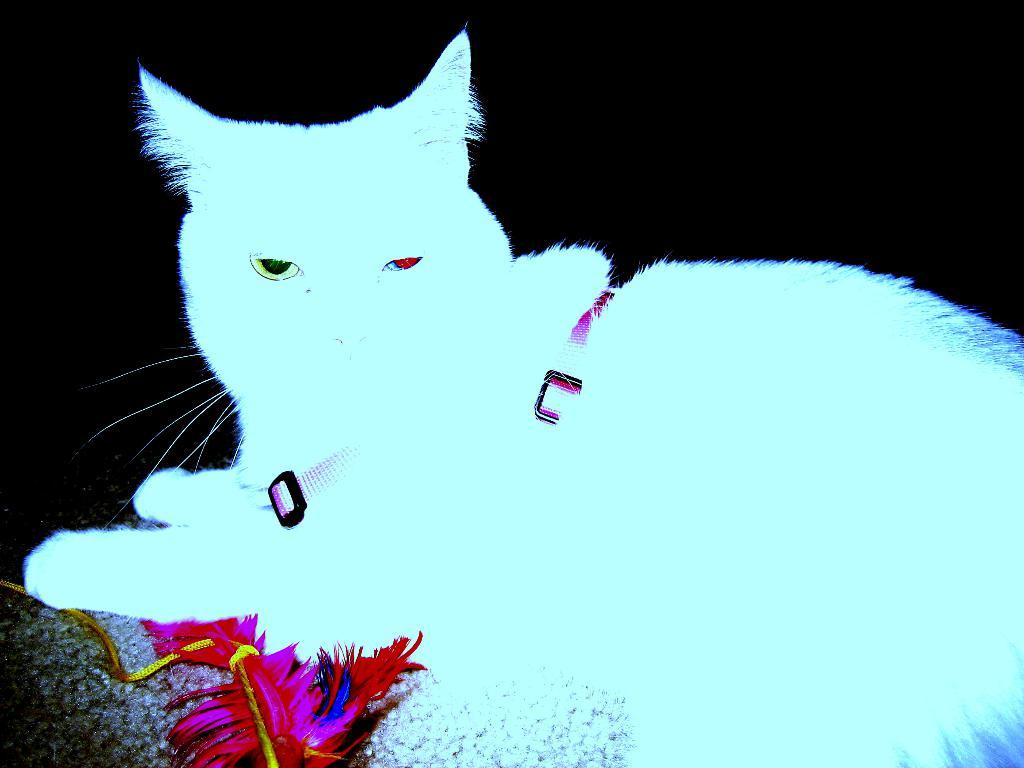What is the main subject of the poster in the image? The poster features a cat. Where is the poster located in the image? The poster is in the center of the image. Can you describe the poster's position in relation to other elements in the image? The poster is the main focus of the image, with no other elements directly overlapping or obscuring it. How does the cat push the print button in the image? There is no print button or action of pushing in the image; it only features a poster with a cat. 